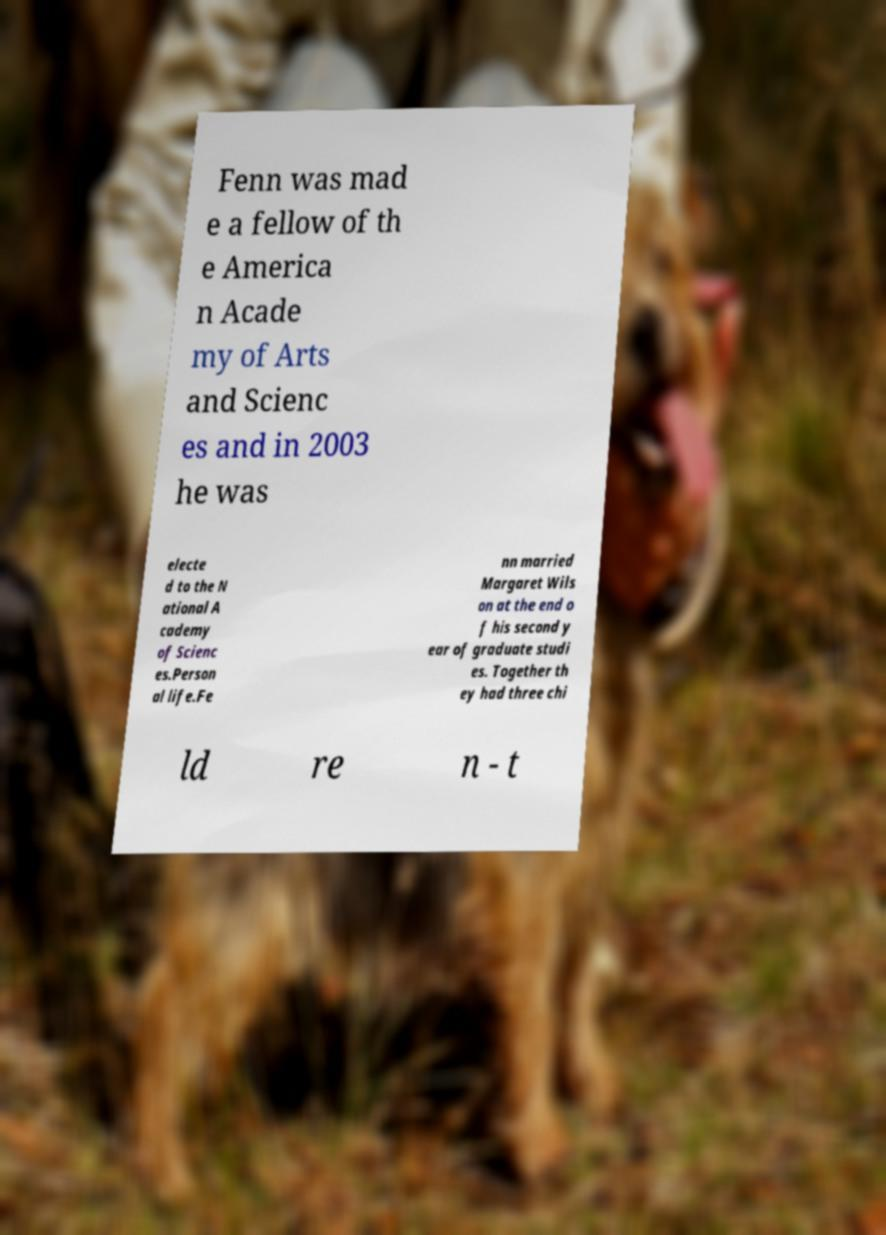I need the written content from this picture converted into text. Can you do that? Fenn was mad e a fellow of th e America n Acade my of Arts and Scienc es and in 2003 he was electe d to the N ational A cademy of Scienc es.Person al life.Fe nn married Margaret Wils on at the end o f his second y ear of graduate studi es. Together th ey had three chi ld re n - t 